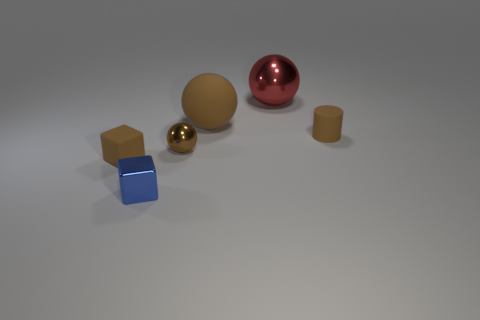Add 3 small rubber cylinders. How many objects exist? 9 Subtract all blocks. How many objects are left? 4 Add 3 small cylinders. How many small cylinders exist? 4 Subtract 0 gray spheres. How many objects are left? 6 Subtract all big metallic things. Subtract all big brown things. How many objects are left? 4 Add 6 tiny blue shiny cubes. How many tiny blue shiny cubes are left? 7 